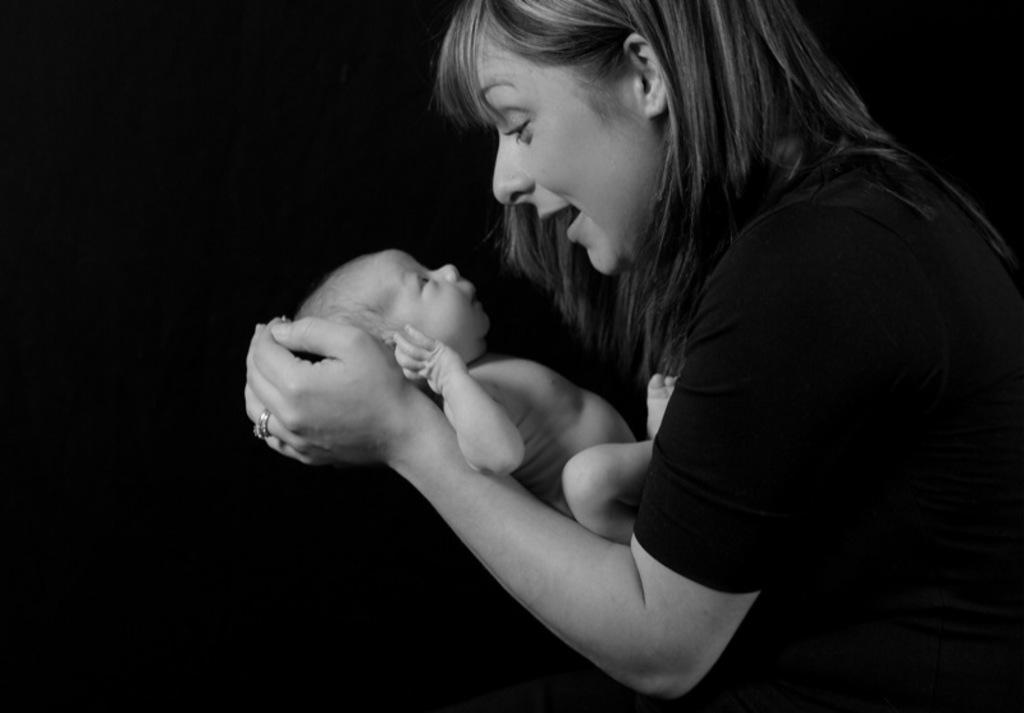Please provide a concise description of this image. In this image we can see a woman holding a baby in her hand. 